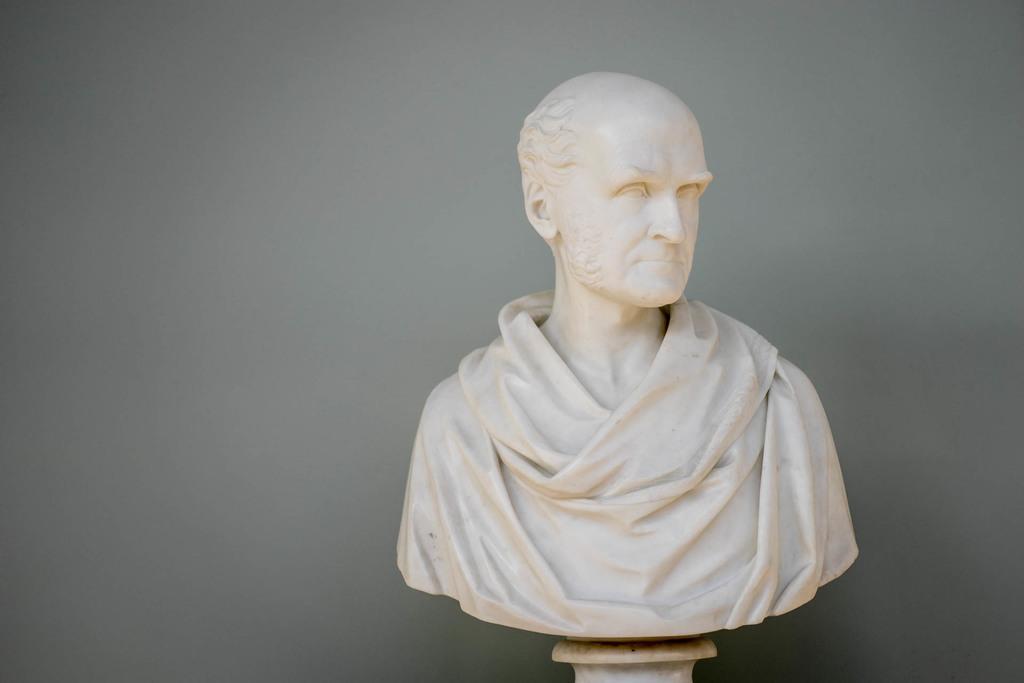Can you describe this image briefly? In the center of the picture there is a sculpture. In the background there is a grey color wall. 